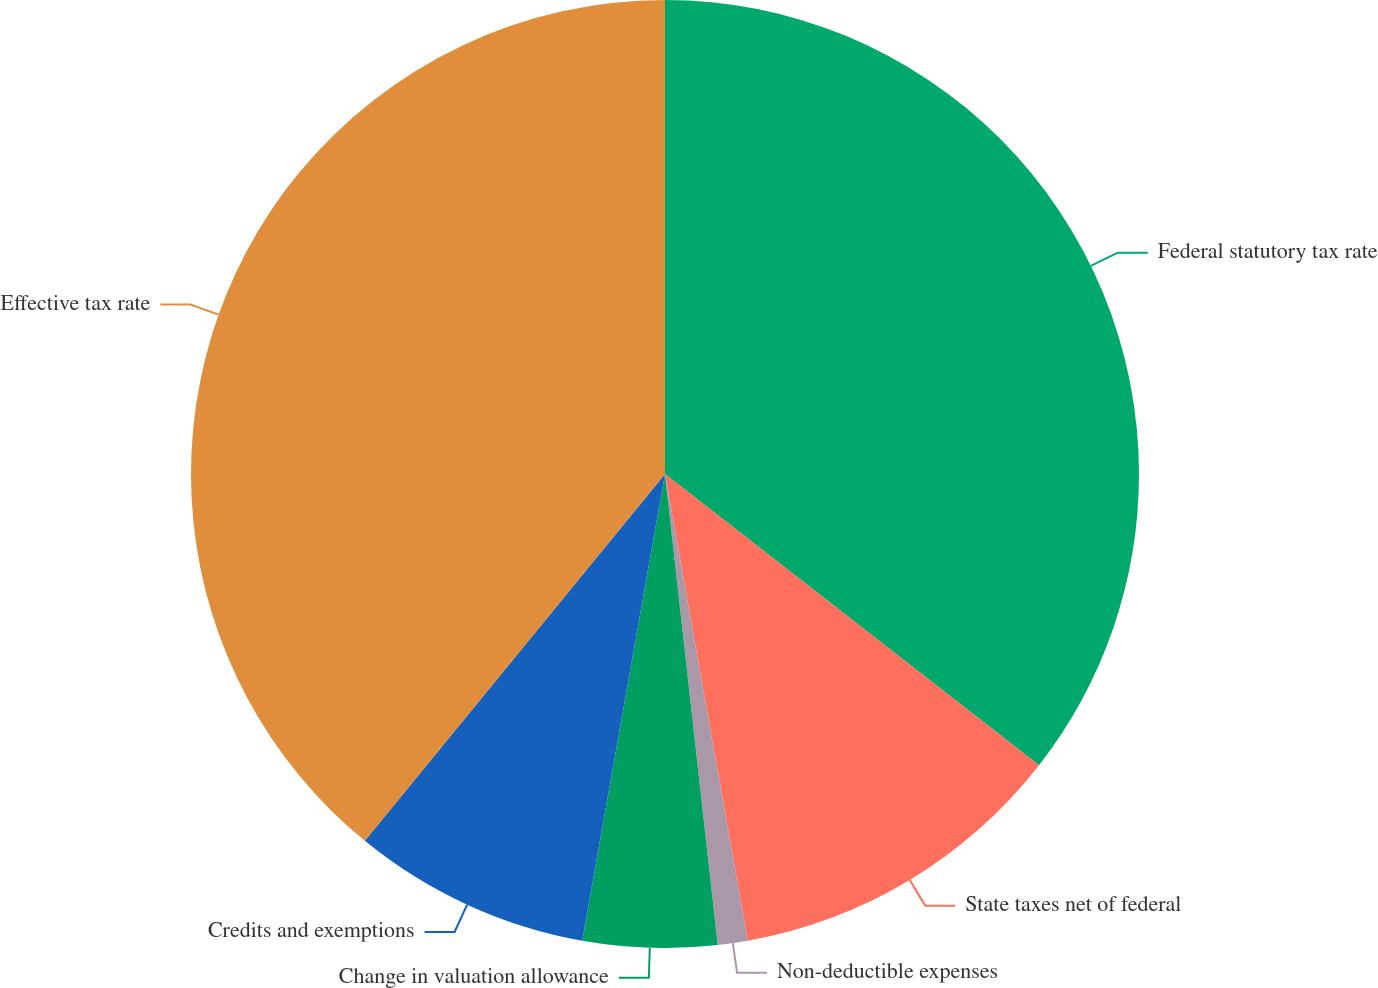Convert chart. <chart><loc_0><loc_0><loc_500><loc_500><pie_chart><fcel>Federal statutory tax rate<fcel>State taxes net of federal<fcel>Non-deductible expenses<fcel>Change in valuation allowance<fcel>Credits and exemptions<fcel>Effective tax rate<nl><fcel>35.53%<fcel>11.68%<fcel>1.02%<fcel>4.57%<fcel>8.12%<fcel>39.09%<nl></chart> 